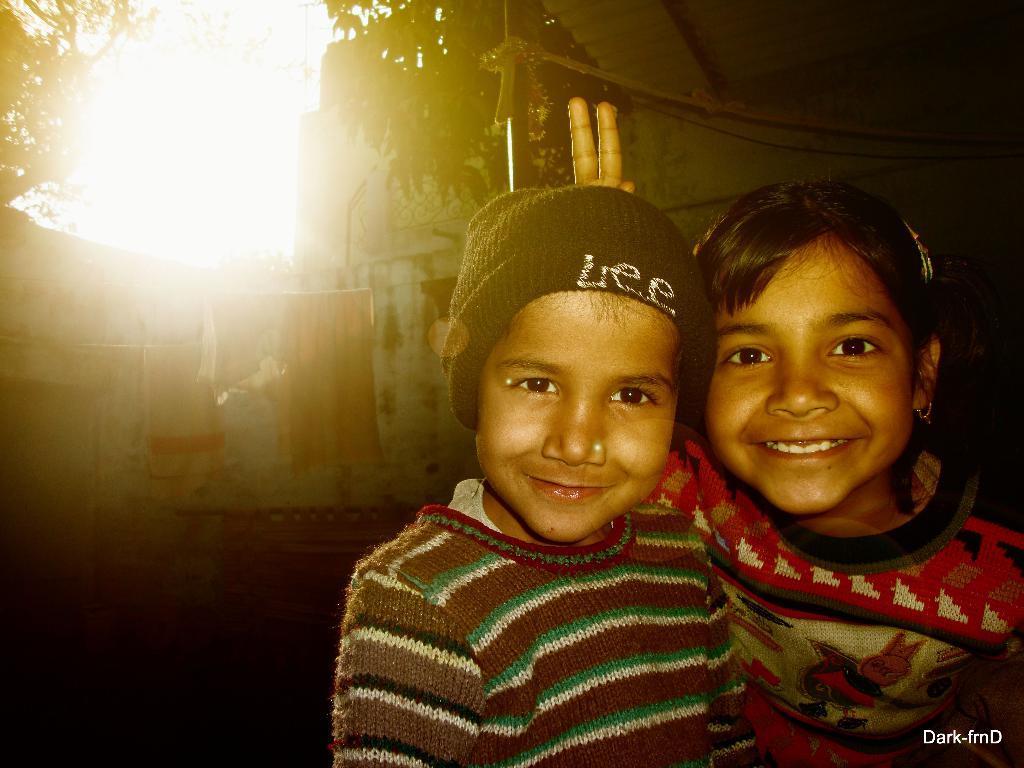Please provide a concise description of this image. In this image I can see two children in the front and I can see both of them are smiling. I can see both of them are wearing sweaters and I can also see one of them is wearing a cap. I can see something is written on the cap. In the background I can see few buildings, the sun and number of clothes on the ropes. On the right side of the image, I can see few more ropes and on the bottom right side I can see a watermark. 